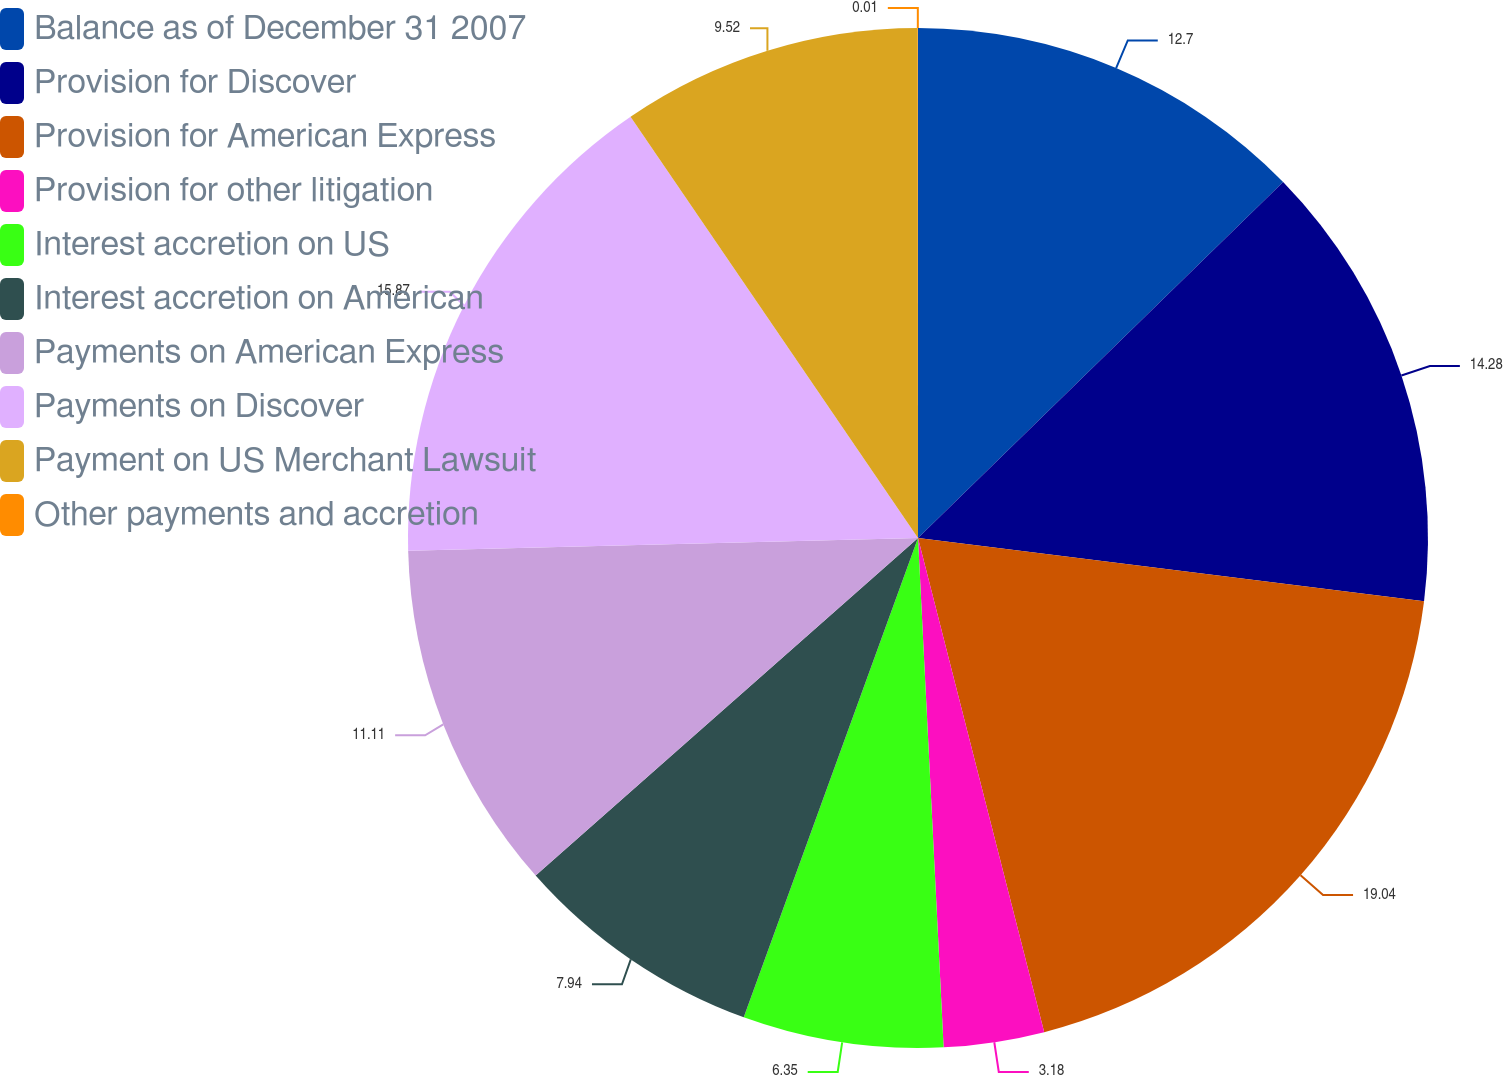<chart> <loc_0><loc_0><loc_500><loc_500><pie_chart><fcel>Balance as of December 31 2007<fcel>Provision for Discover<fcel>Provision for American Express<fcel>Provision for other litigation<fcel>Interest accretion on US<fcel>Interest accretion on American<fcel>Payments on American Express<fcel>Payments on Discover<fcel>Payment on US Merchant Lawsuit<fcel>Other payments and accretion<nl><fcel>12.7%<fcel>14.28%<fcel>19.04%<fcel>3.18%<fcel>6.35%<fcel>7.94%<fcel>11.11%<fcel>15.87%<fcel>9.52%<fcel>0.01%<nl></chart> 